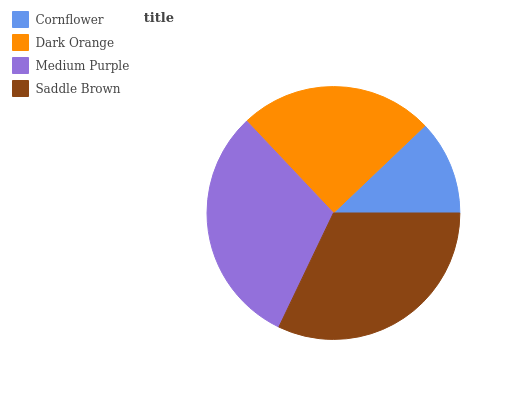Is Cornflower the minimum?
Answer yes or no. Yes. Is Saddle Brown the maximum?
Answer yes or no. Yes. Is Dark Orange the minimum?
Answer yes or no. No. Is Dark Orange the maximum?
Answer yes or no. No. Is Dark Orange greater than Cornflower?
Answer yes or no. Yes. Is Cornflower less than Dark Orange?
Answer yes or no. Yes. Is Cornflower greater than Dark Orange?
Answer yes or no. No. Is Dark Orange less than Cornflower?
Answer yes or no. No. Is Medium Purple the high median?
Answer yes or no. Yes. Is Dark Orange the low median?
Answer yes or no. Yes. Is Cornflower the high median?
Answer yes or no. No. Is Cornflower the low median?
Answer yes or no. No. 